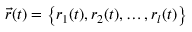<formula> <loc_0><loc_0><loc_500><loc_500>\vec { r } ( t ) = \left \{ r _ { 1 } ( t ) , r _ { 2 } ( t ) , \dots , r _ { l } ( t ) \right \}</formula> 